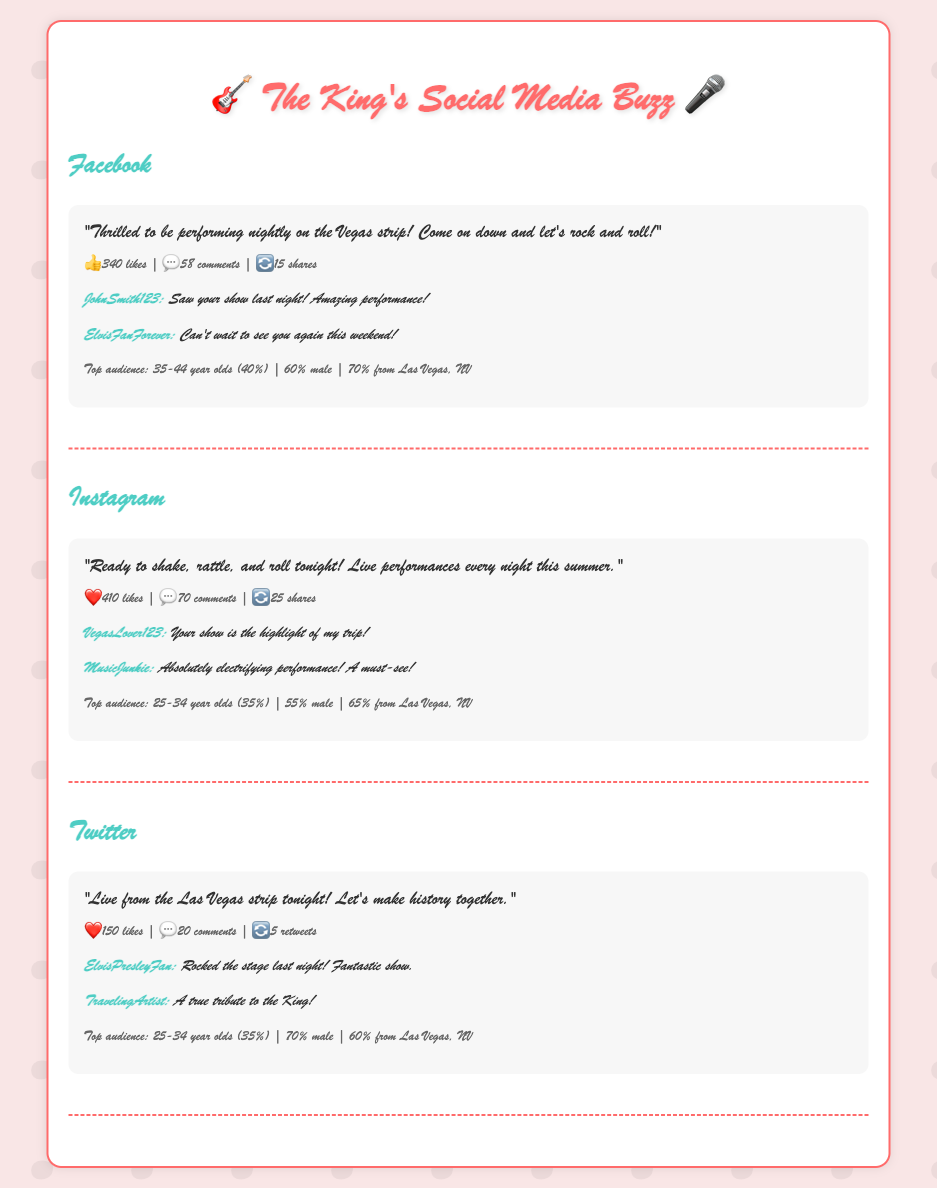what was the Facebook post about? The Facebook post expresses excitement about performing on the Vegas strip and invites people to join.
Answer: "Thrilled to be performing nightly on the Vegas strip! Come on down and let's rock and roll!" how many comments did the Instagram post receive? The Instagram post received a total of 70 comments.
Answer: 70 comments what is the top audience age group for Twitter? The top audience age group for Twitter is specified as 25-34 year olds.
Answer: 25-34 year olds which social media platform had the most likes on a post? The Instagram platform had the most likes with 410 likes.
Answer: 410 likes who commented positively about the show on Twitter? "ElvisPresleyFan" and "TravelingArtist" both commented positively about the show on Twitter.
Answer: ElvisPresleyFan, TravelingArtist what percentage of the Facebook audience is male? The document states that 60% of the Facebook audience is male.
Answer: 60% male 